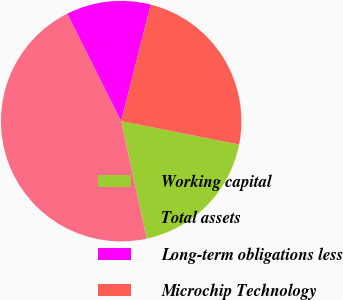Convert chart. <chart><loc_0><loc_0><loc_500><loc_500><pie_chart><fcel>Working capital<fcel>Total assets<fcel>Long-term obligations less<fcel>Microchip Technology<nl><fcel>18.48%<fcel>46.02%<fcel>11.35%<fcel>24.16%<nl></chart> 